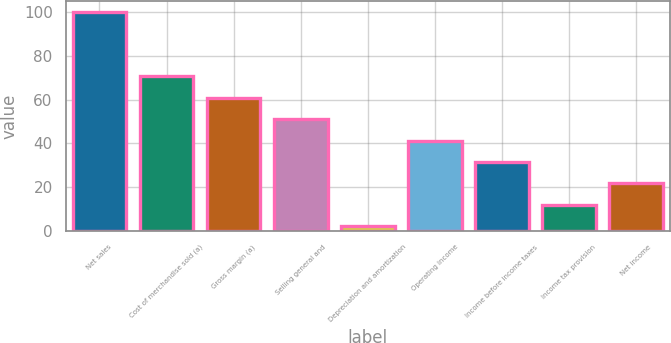<chart> <loc_0><loc_0><loc_500><loc_500><bar_chart><fcel>Net sales<fcel>Cost of merchandise sold (a)<fcel>Gross margin (a)<fcel>Selling general and<fcel>Depreciation and amortization<fcel>Operating income<fcel>Income before income taxes<fcel>Income tax provision<fcel>Net income<nl><fcel>100<fcel>70.63<fcel>60.84<fcel>51.05<fcel>2.1<fcel>41.26<fcel>31.47<fcel>11.89<fcel>21.68<nl></chart> 